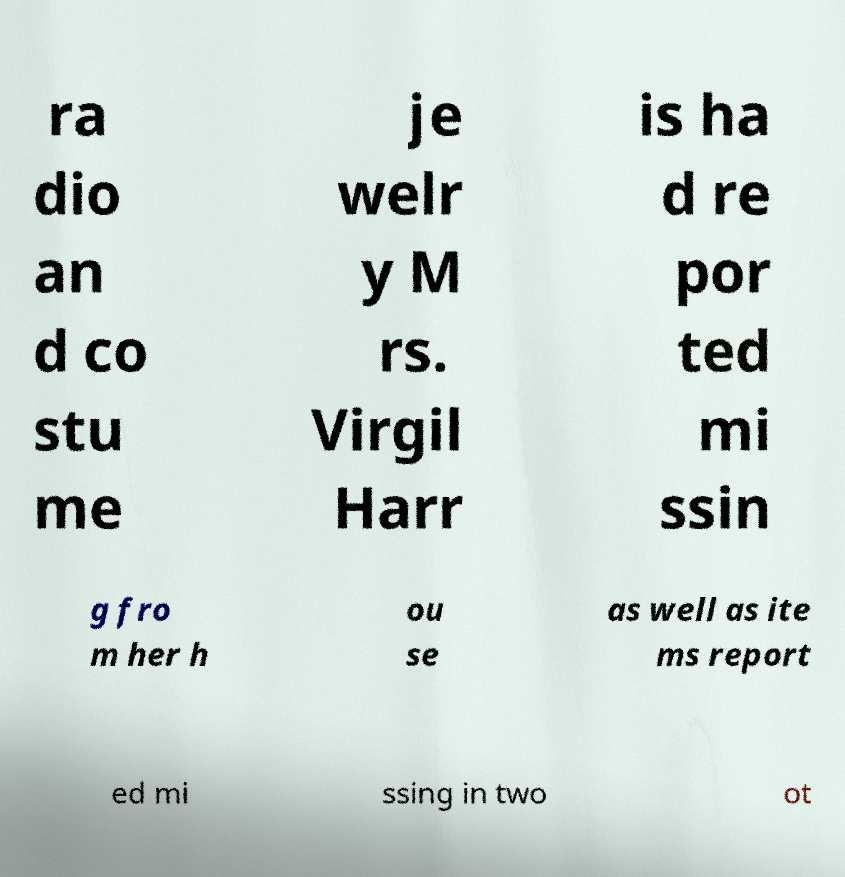Please identify and transcribe the text found in this image. ra dio an d co stu me je welr y M rs. Virgil Harr is ha d re por ted mi ssin g fro m her h ou se as well as ite ms report ed mi ssing in two ot 